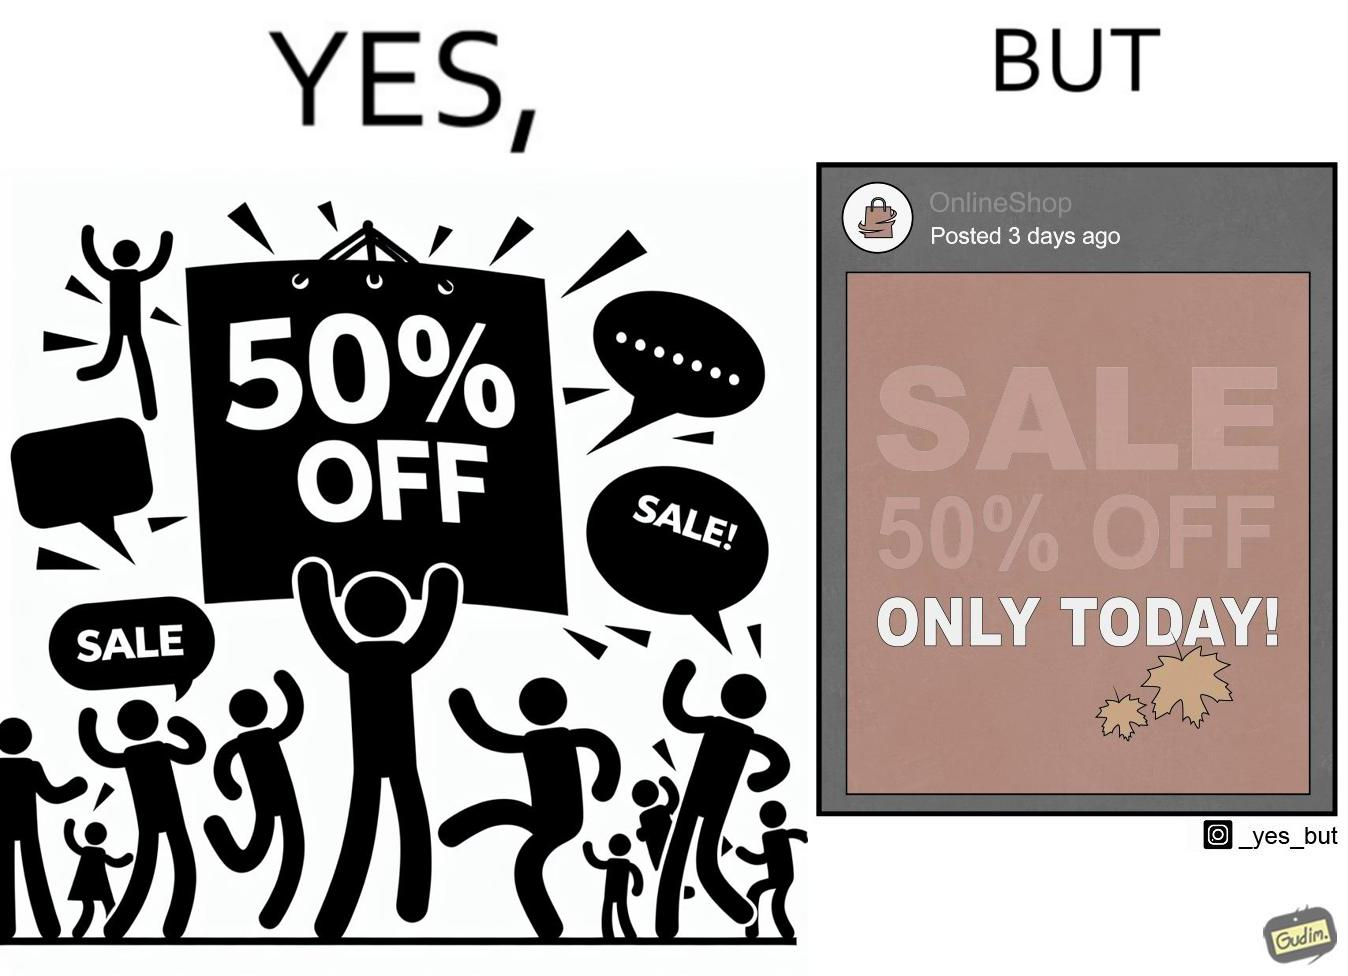Why is this image considered satirical? The image is ironic, because the poster of sale at a store is posted 3 days ago on a social media account which means the sale which was for only one day has become over 